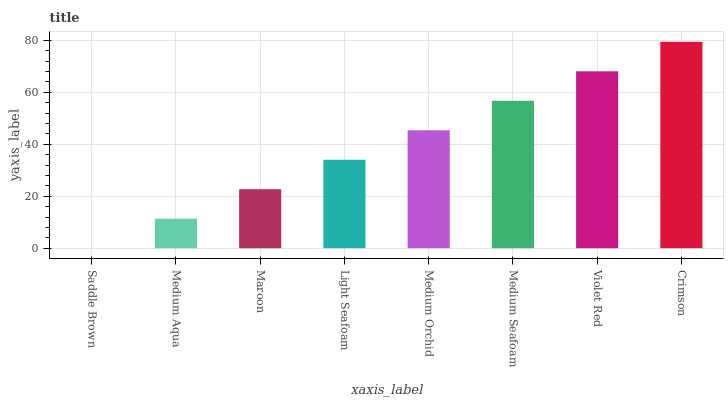Is Saddle Brown the minimum?
Answer yes or no. Yes. Is Crimson the maximum?
Answer yes or no. Yes. Is Medium Aqua the minimum?
Answer yes or no. No. Is Medium Aqua the maximum?
Answer yes or no. No. Is Medium Aqua greater than Saddle Brown?
Answer yes or no. Yes. Is Saddle Brown less than Medium Aqua?
Answer yes or no. Yes. Is Saddle Brown greater than Medium Aqua?
Answer yes or no. No. Is Medium Aqua less than Saddle Brown?
Answer yes or no. No. Is Medium Orchid the high median?
Answer yes or no. Yes. Is Light Seafoam the low median?
Answer yes or no. Yes. Is Violet Red the high median?
Answer yes or no. No. Is Medium Aqua the low median?
Answer yes or no. No. 